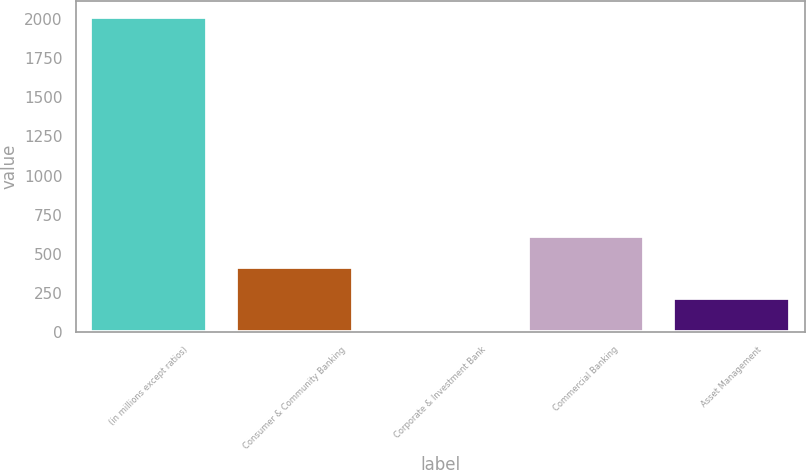<chart> <loc_0><loc_0><loc_500><loc_500><bar_chart><fcel>(in millions except ratios)<fcel>Consumer & Community Banking<fcel>Corporate & Investment Bank<fcel>Commercial Banking<fcel>Asset Management<nl><fcel>2012<fcel>416.8<fcel>18<fcel>616.2<fcel>217.4<nl></chart> 